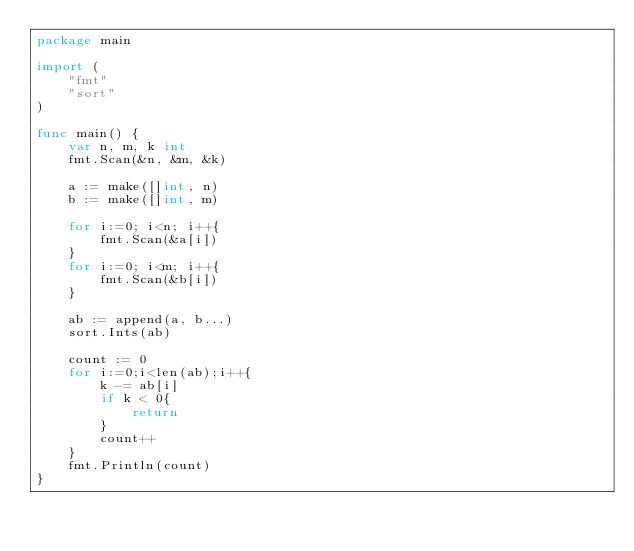<code> <loc_0><loc_0><loc_500><loc_500><_Go_>package main

import (
	"fmt"
	"sort"
)

func main() {
	var n, m, k int
	fmt.Scan(&n, &m, &k)

	a := make([]int, n)
	b := make([]int, m)

	for i:=0; i<n; i++{
		fmt.Scan(&a[i])
	}
	for i:=0; i<m; i++{
		fmt.Scan(&b[i])
	}

	ab := append(a, b...)
	sort.Ints(ab)

	count := 0
	for i:=0;i<len(ab);i++{
		k -= ab[i]
		if k < 0{
			return
		}
		count++
	}
	fmt.Println(count)
}</code> 